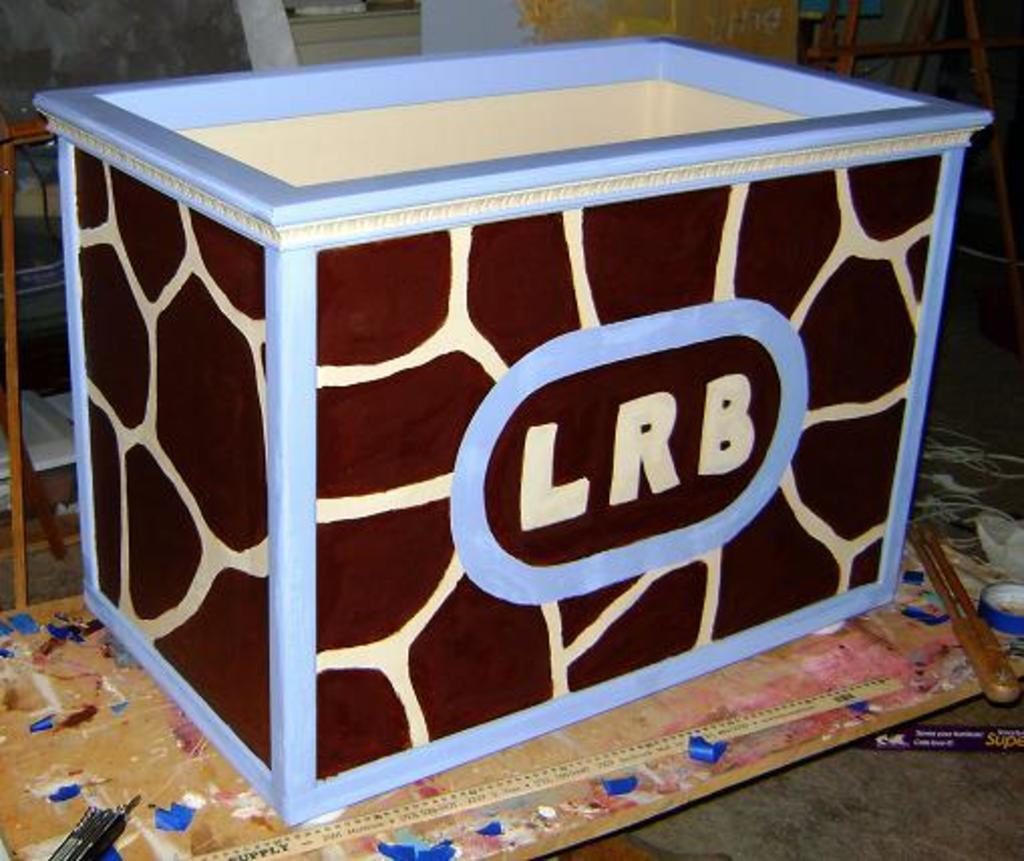What object is located at the center of the image? There is a box in the image, and it is placed at the center. Where is the box situated in relation to the floor? The box is on the surface of the floor. What type of rice can be seen growing near the box in the image? There is no rice present in the image, and the box is not near any rice. 